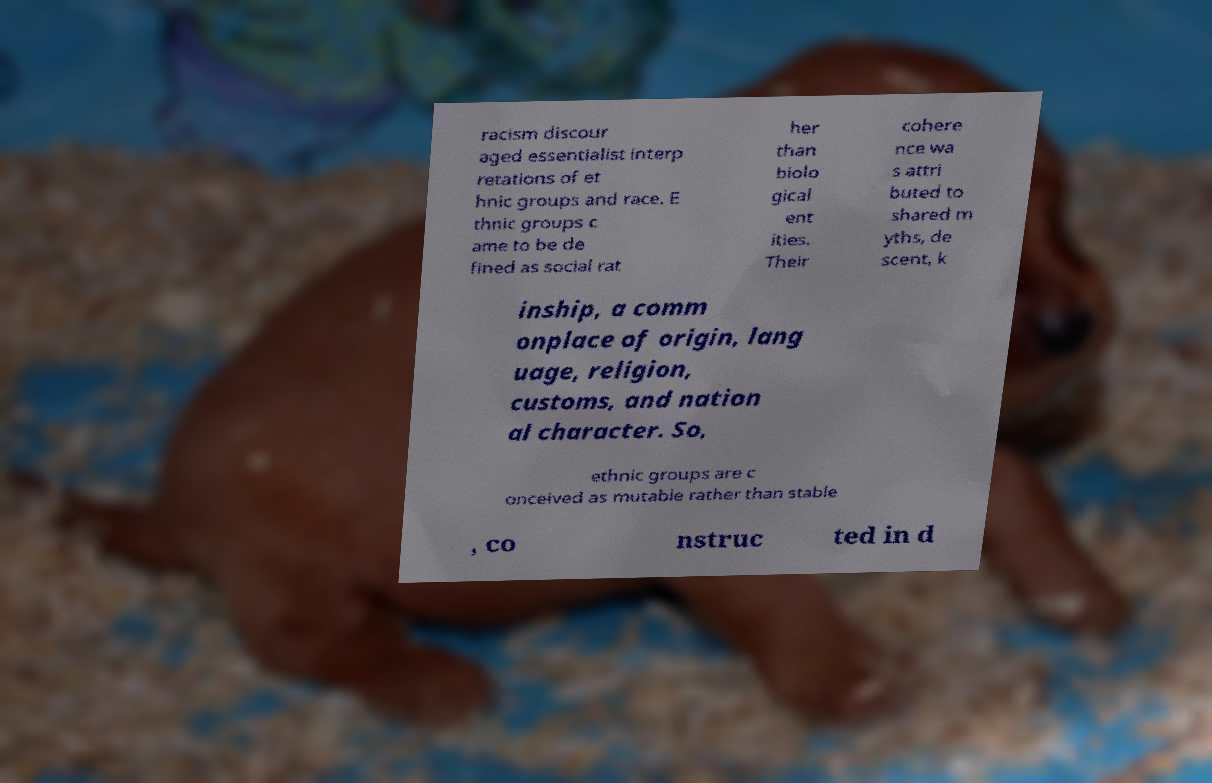I need the written content from this picture converted into text. Can you do that? racism discour aged essentialist interp retations of et hnic groups and race. E thnic groups c ame to be de fined as social rat her than biolo gical ent ities. Their cohere nce wa s attri buted to shared m yths, de scent, k inship, a comm onplace of origin, lang uage, religion, customs, and nation al character. So, ethnic groups are c onceived as mutable rather than stable , co nstruc ted in d 